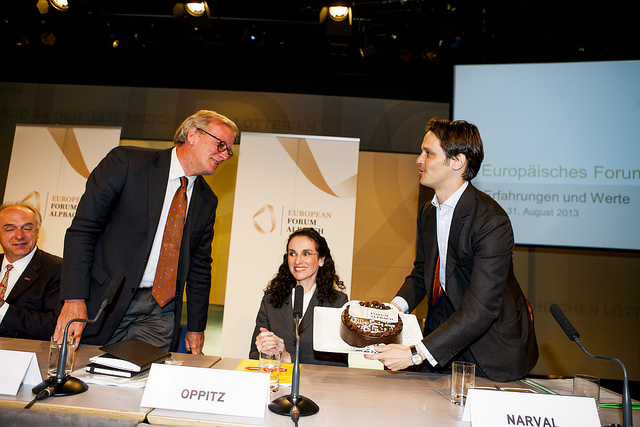Identify the text displayed in this image. OPPITE NARVAI Europaisches 2013 Forun Werte and rfahrungen 